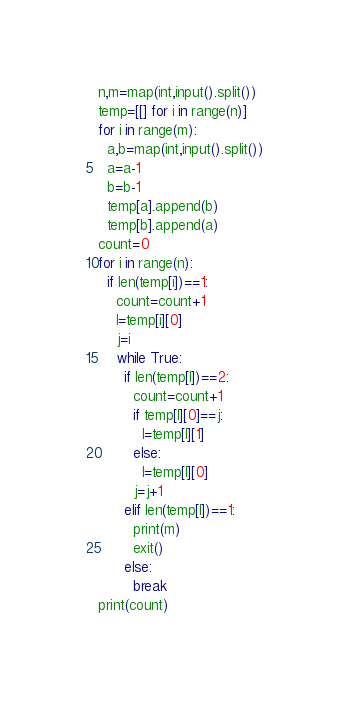<code> <loc_0><loc_0><loc_500><loc_500><_Python_>n,m=map(int,input().split())
temp=[[] for i in range(n)]
for i in range(m):
  a,b=map(int,input().split())
  a=a-1
  b=b-1
  temp[a].append(b)
  temp[b].append(a)
count=0
for i in range(n):
  if len(temp[i])==1:
    count=count+1
    l=temp[i][0]
    j=i
    while True:
      if len(temp[l])==2:
        count=count+1
        if temp[l][0]==j:
          l=temp[l][1]
        else:
          l=temp[l][0]
        j=j+1
      elif len(temp[l])==1:
        print(m)
        exit()
      else:
        break
print(count)</code> 